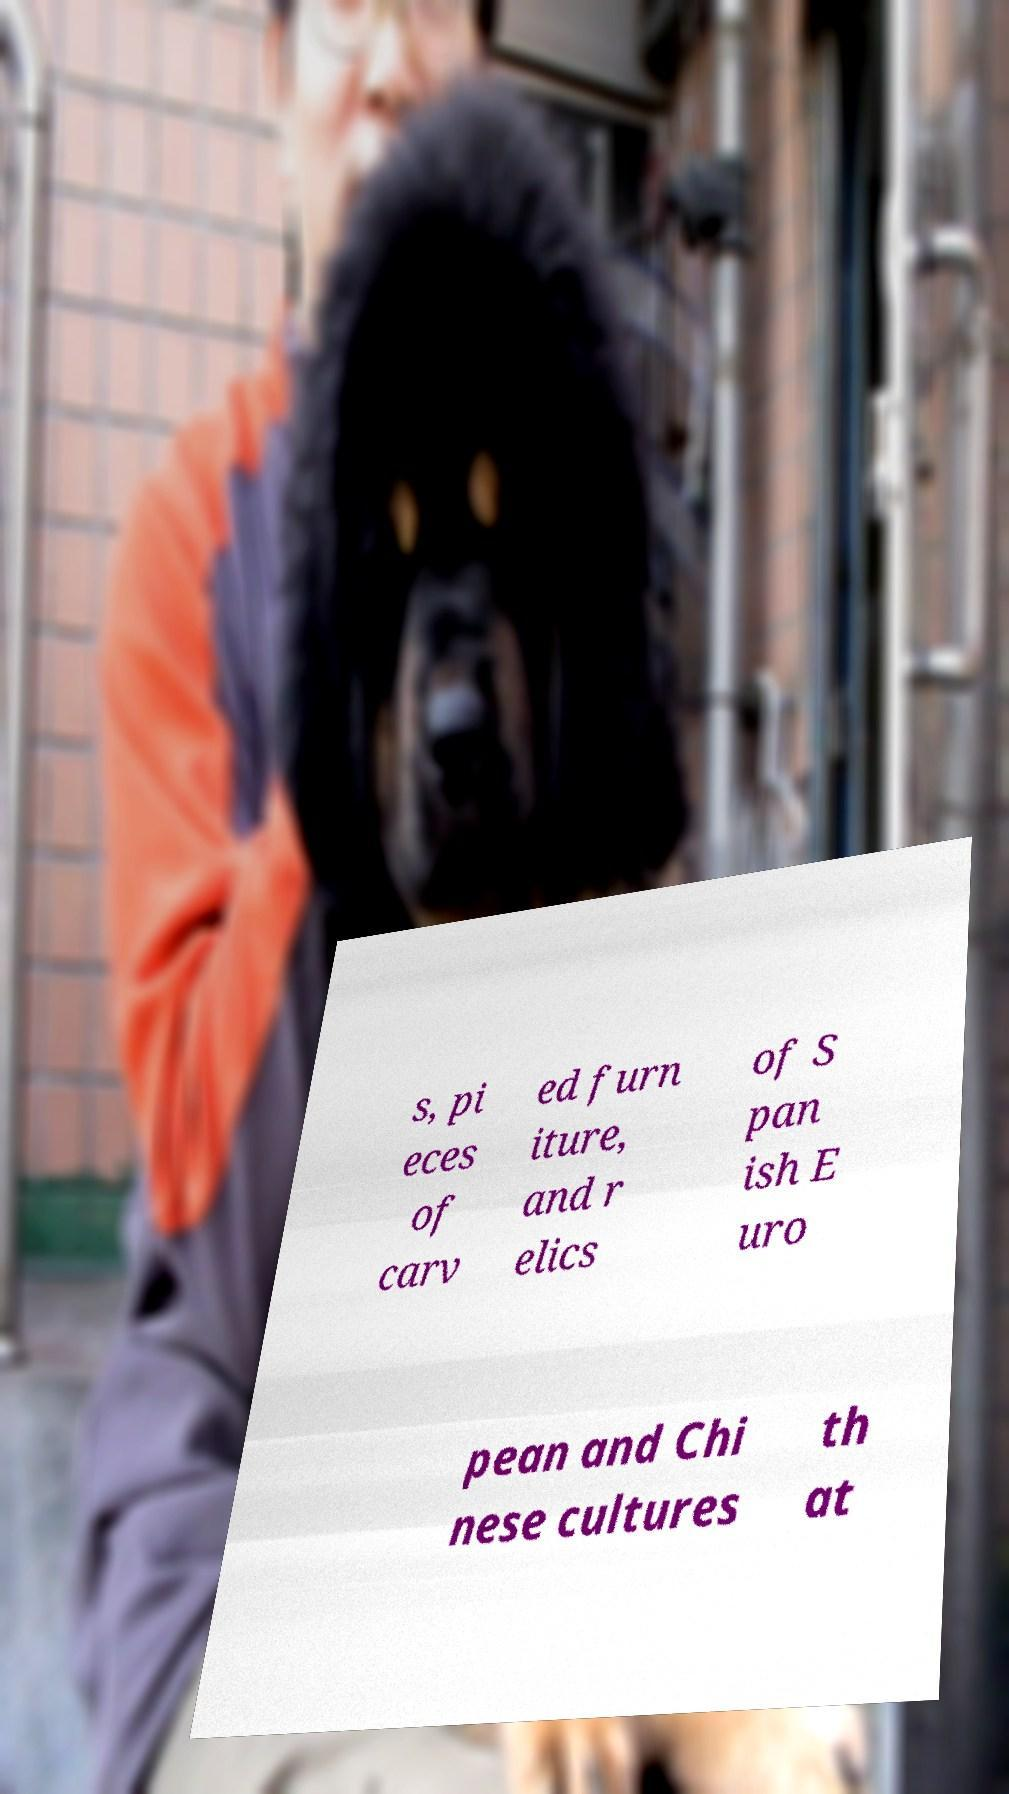Could you extract and type out the text from this image? s, pi eces of carv ed furn iture, and r elics of S pan ish E uro pean and Chi nese cultures th at 